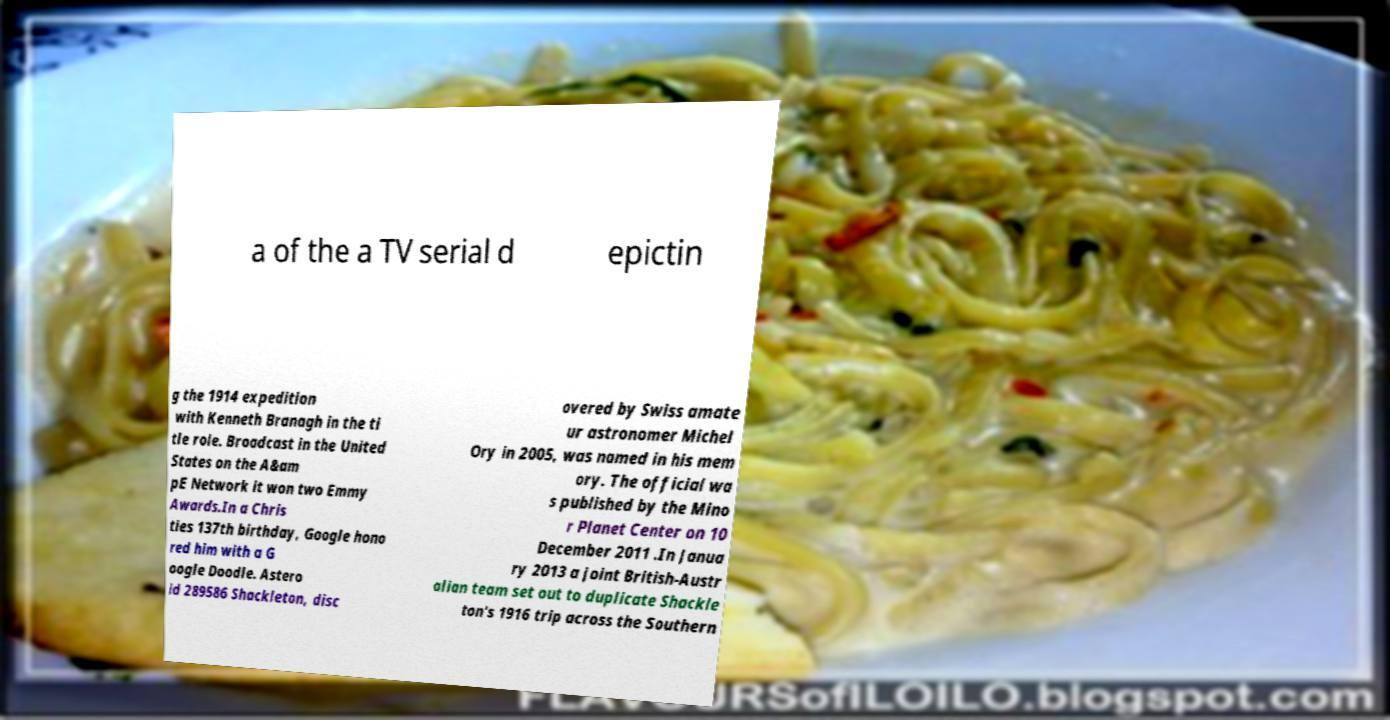Can you read and provide the text displayed in the image?This photo seems to have some interesting text. Can you extract and type it out for me? a of the a TV serial d epictin g the 1914 expedition with Kenneth Branagh in the ti tle role. Broadcast in the United States on the A&am pE Network it won two Emmy Awards.In a Chris ties 137th birthday, Google hono red him with a G oogle Doodle. Astero id 289586 Shackleton, disc overed by Swiss amate ur astronomer Michel Ory in 2005, was named in his mem ory. The official wa s published by the Mino r Planet Center on 10 December 2011 .In Janua ry 2013 a joint British-Austr alian team set out to duplicate Shackle ton's 1916 trip across the Southern 